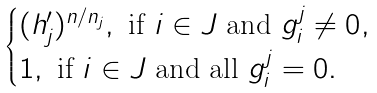<formula> <loc_0><loc_0><loc_500><loc_500>\begin{cases} ( h ^ { \prime } _ { j } ) ^ { n / n _ { j } } , \ \text {if $i\in J$ and $g_{i}^{j}\neq 0$} , \\ 1 , \ \text {if $i\in J$ and all $g_{i}^{j}=0$} . \\ \end{cases}</formula> 